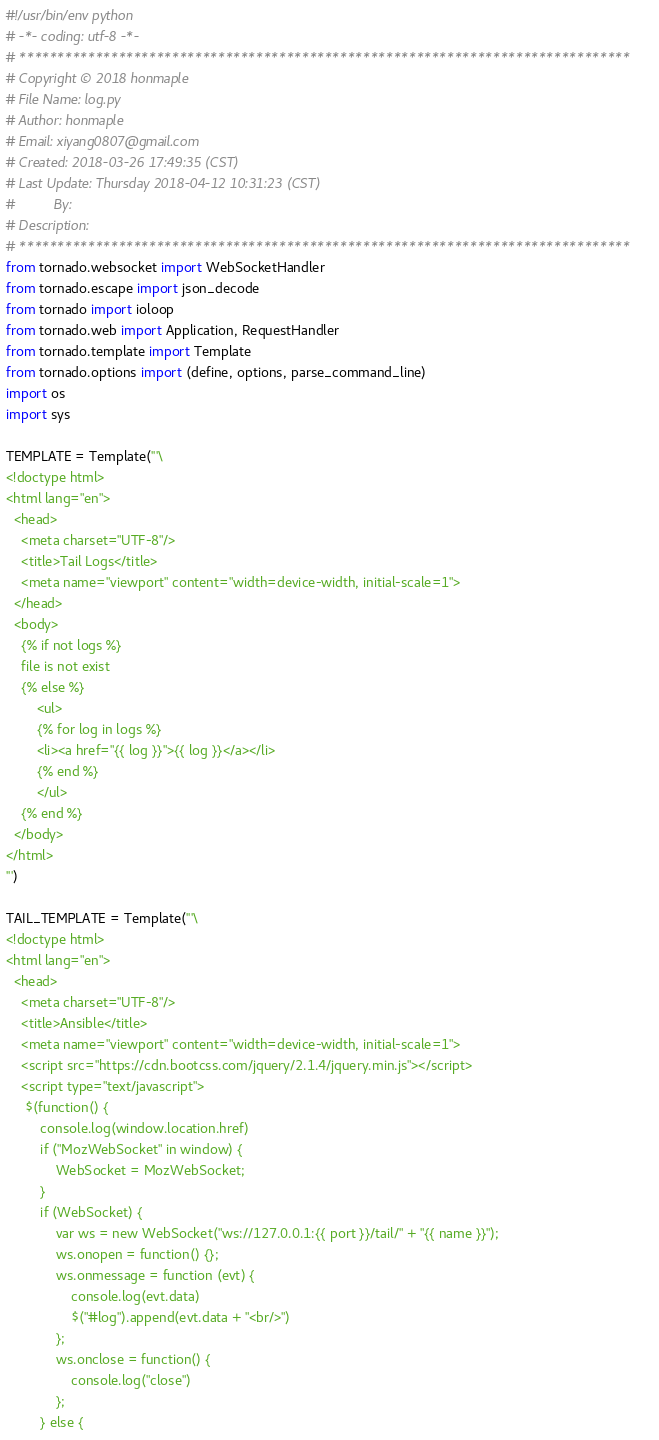<code> <loc_0><loc_0><loc_500><loc_500><_Python_>#!/usr/bin/env python
# -*- coding: utf-8 -*-
# ********************************************************************************
# Copyright © 2018 honmaple
# File Name: log.py
# Author: honmaple
# Email: xiyang0807@gmail.com
# Created: 2018-03-26 17:49:35 (CST)
# Last Update: Thursday 2018-04-12 10:31:23 (CST)
#          By:
# Description:
# ********************************************************************************
from tornado.websocket import WebSocketHandler
from tornado.escape import json_decode
from tornado import ioloop
from tornado.web import Application, RequestHandler
from tornado.template import Template
from tornado.options import (define, options, parse_command_line)
import os
import sys

TEMPLATE = Template('''\
<!doctype html>
<html lang="en">
  <head>
    <meta charset="UTF-8"/>
    <title>Tail Logs</title>
    <meta name="viewport" content="width=device-width, initial-scale=1">
  </head>
  <body>
    {% if not logs %}
    file is not exist
    {% else %}
        <ul>
        {% for log in logs %}
        <li><a href="{{ log }}">{{ log }}</a></li>
        {% end %}
        </ul>
    {% end %}
  </body>
</html>
''')

TAIL_TEMPLATE = Template('''\
<!doctype html>
<html lang="en">
  <head>
    <meta charset="UTF-8"/>
    <title>Ansible</title>
    <meta name="viewport" content="width=device-width, initial-scale=1">
    <script src="https://cdn.bootcss.com/jquery/2.1.4/jquery.min.js"></script>
    <script type="text/javascript">
     $(function() {
         console.log(window.location.href)
         if ("MozWebSocket" in window) {
             WebSocket = MozWebSocket;
         }
         if (WebSocket) {
             var ws = new WebSocket("ws://127.0.0.1:{{ port }}/tail/" + "{{ name }}");
             ws.onopen = function() {};
             ws.onmessage = function (evt) {
                 console.log(evt.data)
                 $("#log").append(evt.data + "<br/>")
             };
             ws.onclose = function() {
                 console.log("close")
             };
         } else {</code> 